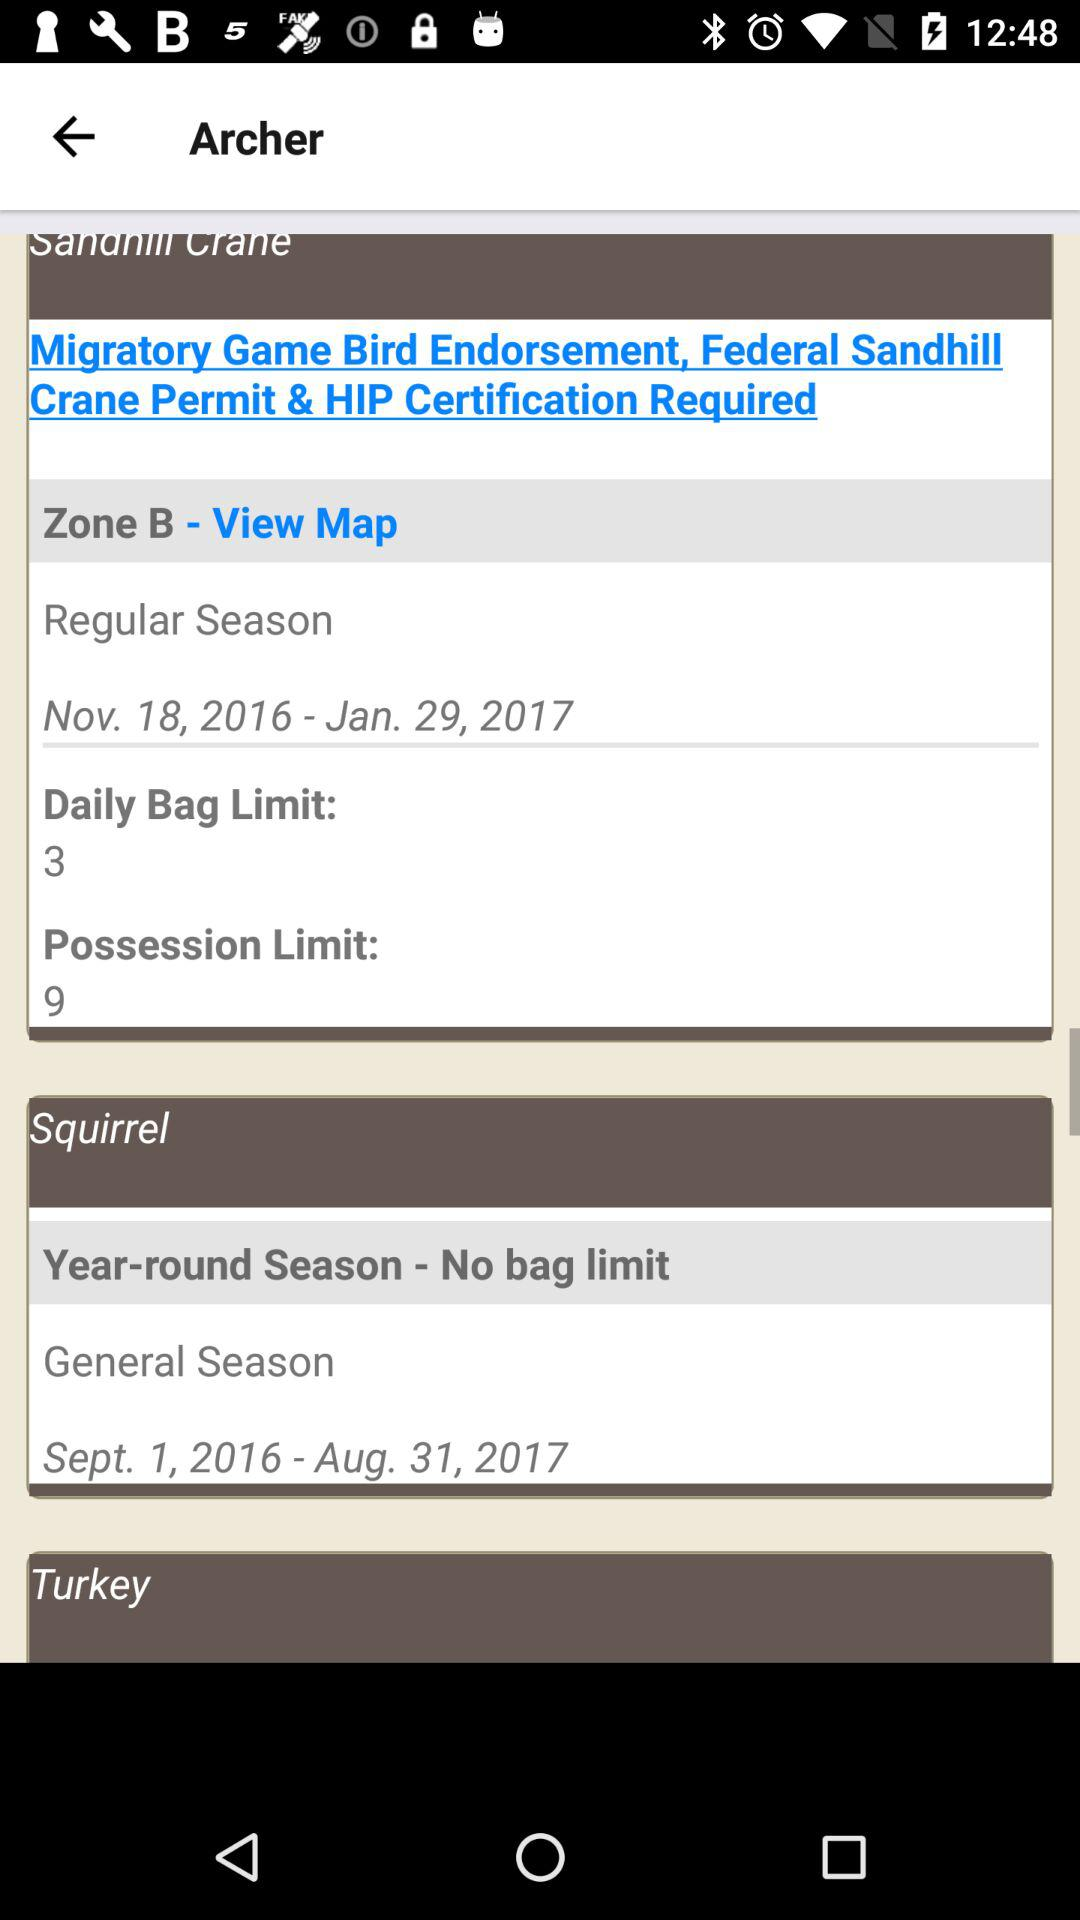What is the daily bag limit? The daily bag limit is 3. 